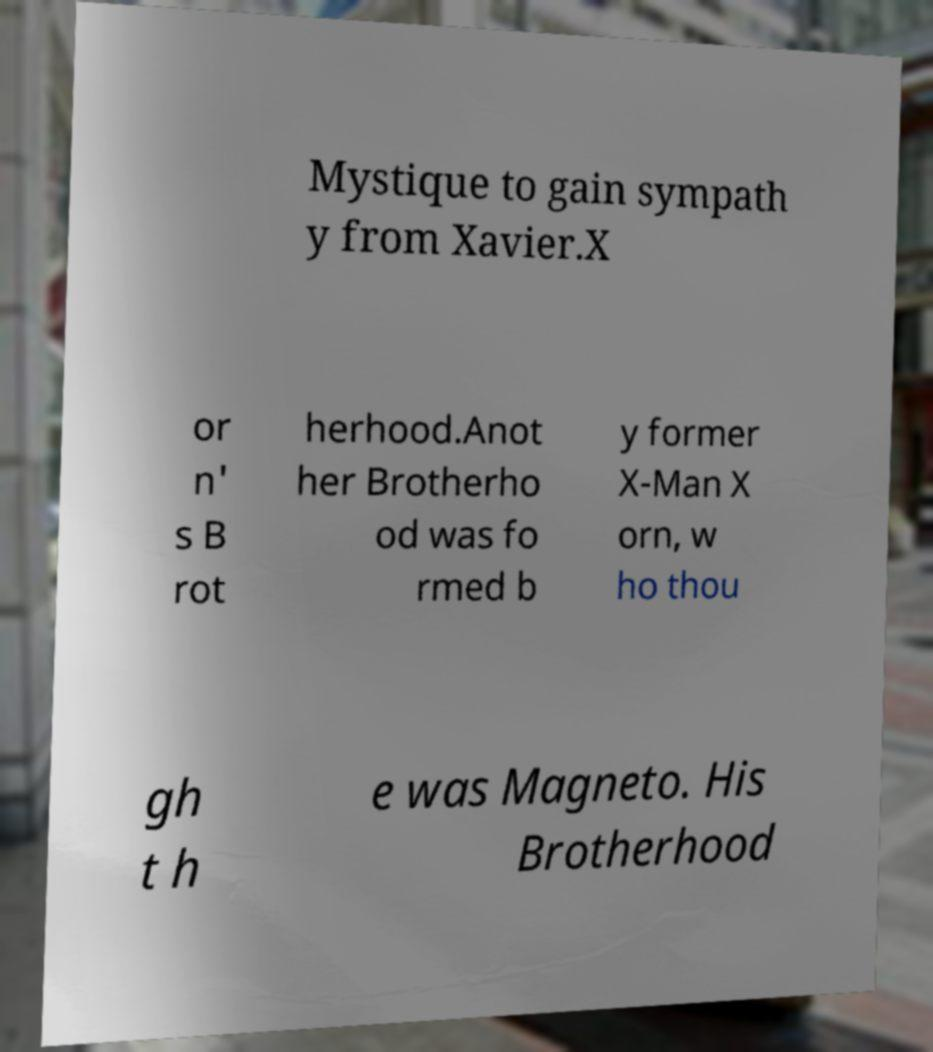Please identify and transcribe the text found in this image. Mystique to gain sympath y from Xavier.X or n' s B rot herhood.Anot her Brotherho od was fo rmed b y former X-Man X orn, w ho thou gh t h e was Magneto. His Brotherhood 